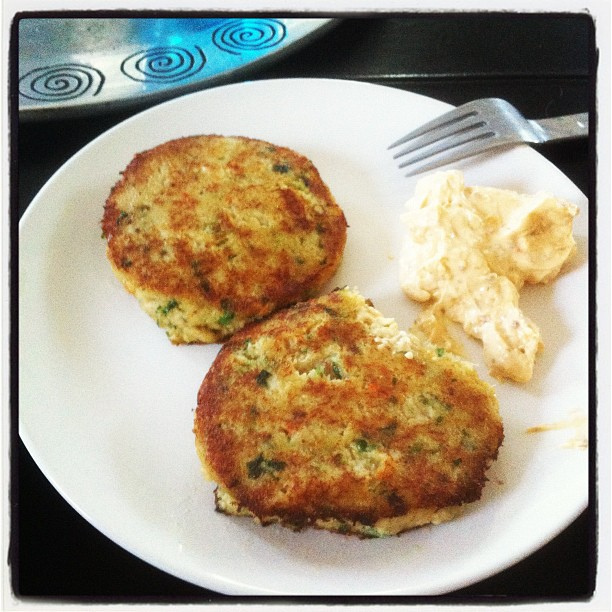<image>What is the design on the platter to the rear? I am not sure. The design on the platter could be spirals, circles or swirls. What is the design on the platter to the rear? The design on the platter to the rear is ambiguous. It can be seen 'spirals', 'circle don't know', 'penis', 'swirling', 'spiral' or 'circles'. 